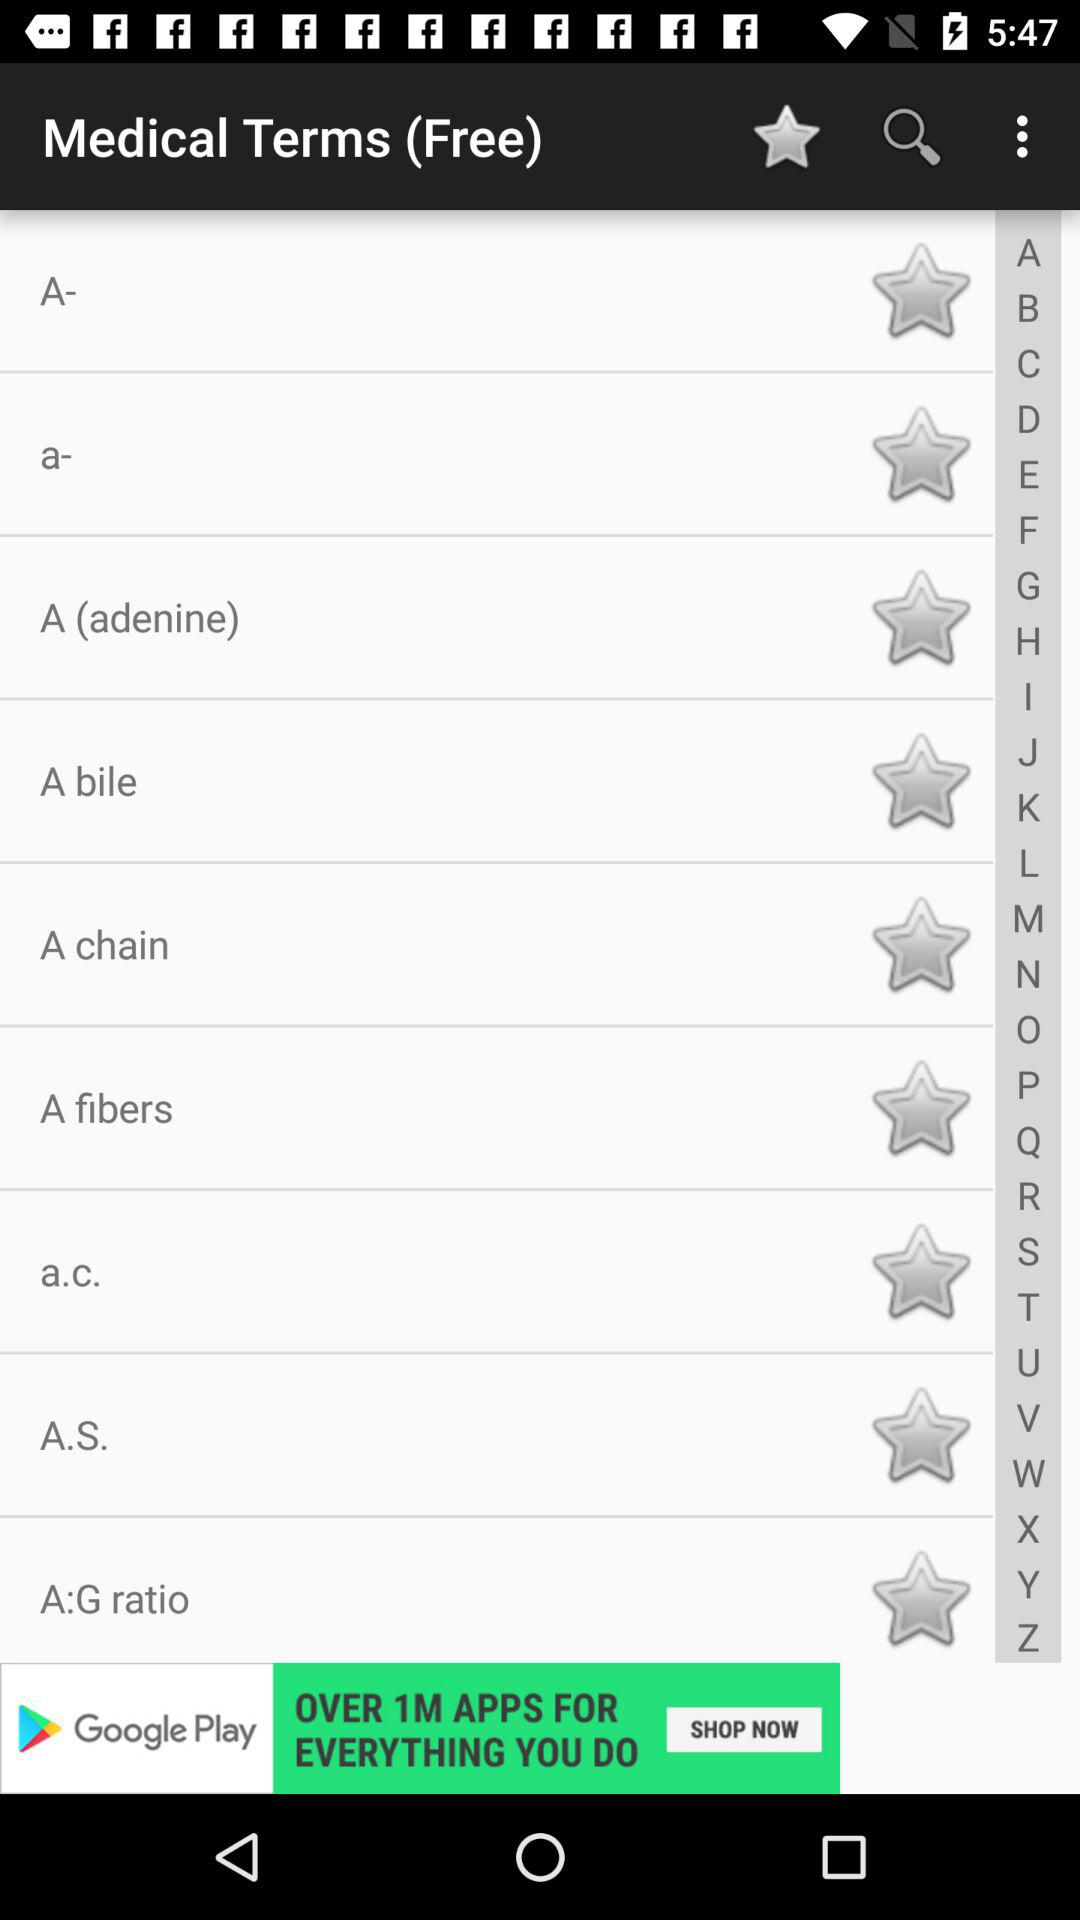How many people have downloaded the free medical terms application?
When the provided information is insufficient, respond with <no answer>. <no answer> 